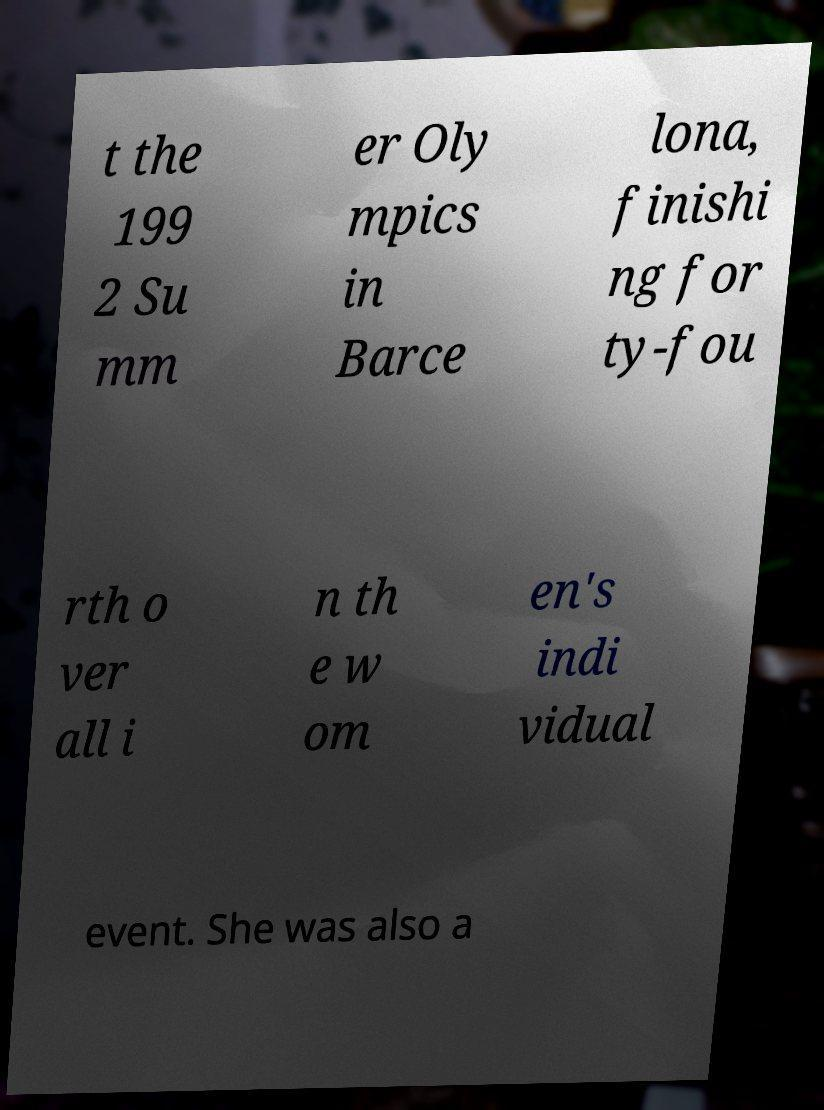For documentation purposes, I need the text within this image transcribed. Could you provide that? t the 199 2 Su mm er Oly mpics in Barce lona, finishi ng for ty-fou rth o ver all i n th e w om en's indi vidual event. She was also a 